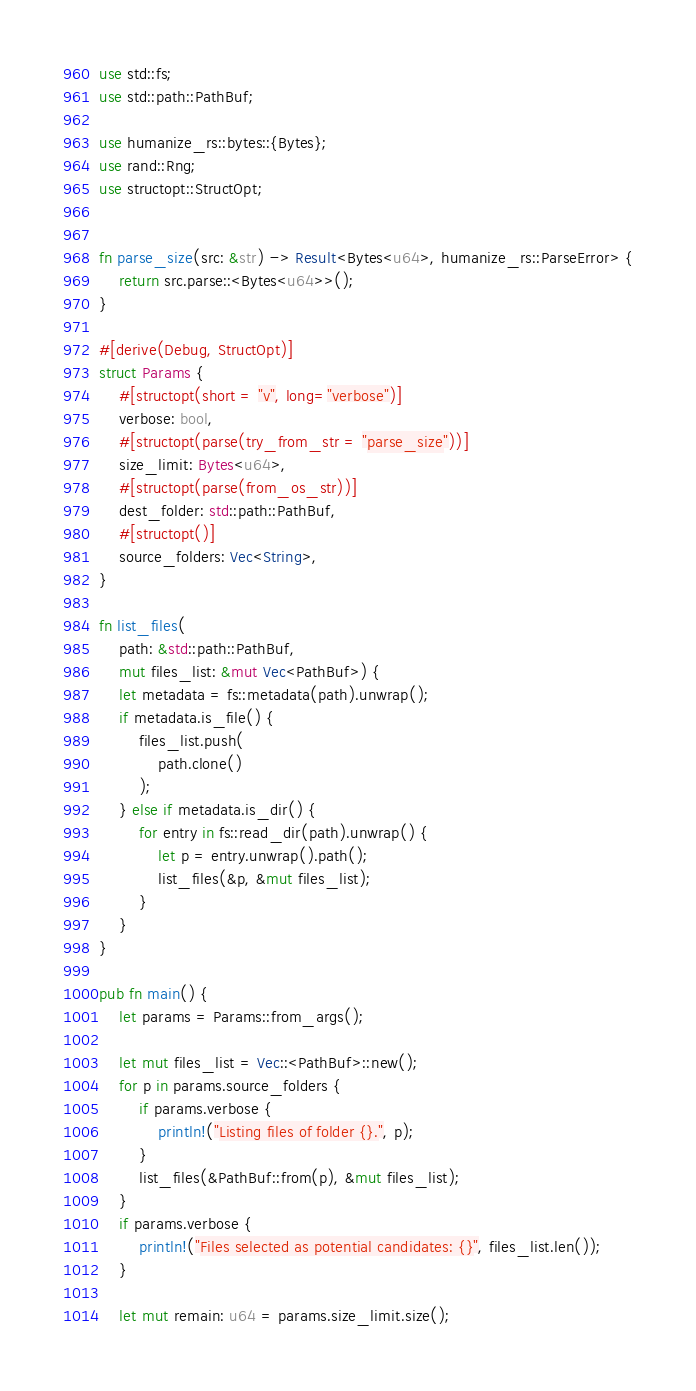<code> <loc_0><loc_0><loc_500><loc_500><_Rust_>use std::fs;
use std::path::PathBuf;

use humanize_rs::bytes::{Bytes};
use rand::Rng;
use structopt::StructOpt;


fn parse_size(src: &str) -> Result<Bytes<u64>, humanize_rs::ParseError> {
    return src.parse::<Bytes<u64>>();
}

#[derive(Debug, StructOpt)]
struct Params {
    #[structopt(short = "v", long="verbose")]
    verbose: bool,
    #[structopt(parse(try_from_str = "parse_size"))]
    size_limit: Bytes<u64>,
    #[structopt(parse(from_os_str))]
    dest_folder: std::path::PathBuf,
    #[structopt()]
    source_folders: Vec<String>,
}

fn list_files(
    path: &std::path::PathBuf,
    mut files_list: &mut Vec<PathBuf>) {
    let metadata = fs::metadata(path).unwrap();
    if metadata.is_file() {
        files_list.push(
            path.clone()
        );
    } else if metadata.is_dir() {
        for entry in fs::read_dir(path).unwrap() {
            let p = entry.unwrap().path();
            list_files(&p, &mut files_list);
        }
    }
}

pub fn main() {
    let params = Params::from_args();

    let mut files_list = Vec::<PathBuf>::new();
    for p in params.source_folders {
        if params.verbose {
            println!("Listing files of folder {}.", p);
        }
        list_files(&PathBuf::from(p), &mut files_list);
    }
    if params.verbose {
        println!("Files selected as potential candidates: {}", files_list.len());
    }

    let mut remain: u64 = params.size_limit.size();
</code> 